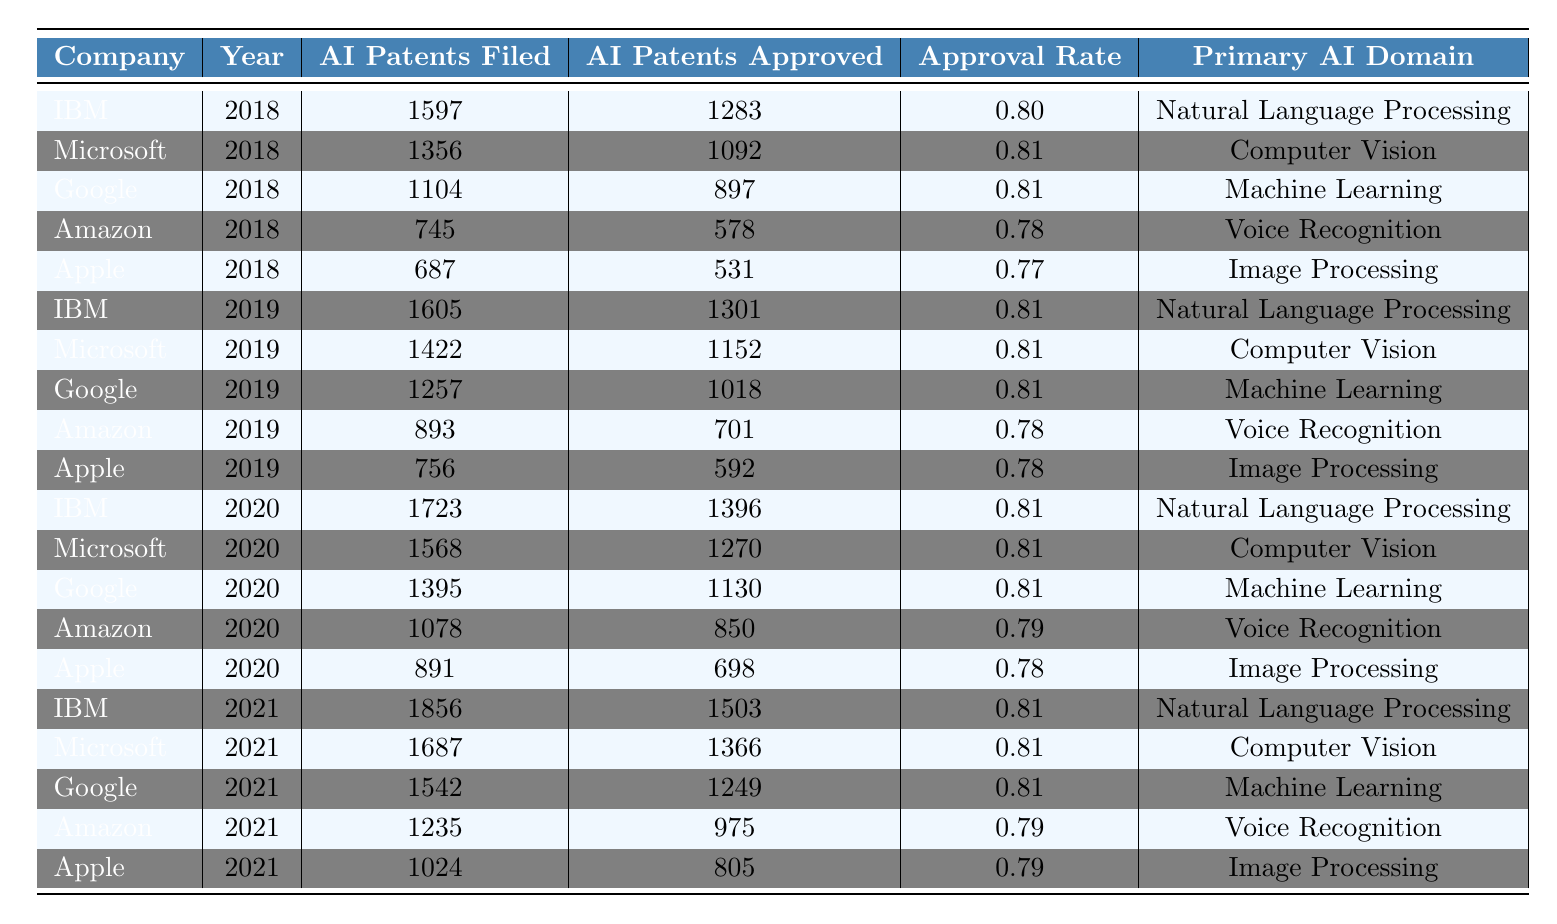What is the approval rate for IBM's AI patents in 2020? IBM filed 1723 AI patents in 2020 and had 1396 approved. The approval rate is calculated as 1396/1723, which equals 0.81.
Answer: 0.81 Which company had the highest number of AI patents filed in 2021? In 2021, IBM filed 1856 AI patents, which is higher than any other company in that year.
Answer: IBM What was the average approval rate for AI patents filed by Apple from 2018 to 2021? Apple's approval rates for 2018, 2019, 2020, and 2021 were 0.77, 0.78, 0.78, and 0.79 respectively. The average is (0.77 + 0.78 + 0.78 + 0.79) / 4 = 0.785.
Answer: 0.785 Did Amazon have a higher approval rate in 2020 compared to 2019? Amazon’s approval rates were 0.79 in 2020 and 0.78 in 2019. Since 0.79 is greater than 0.78, the statement is true.
Answer: Yes Which company consistently maintained an approval rate of 0.81 from 2018 to 2021? The approval rates for Microsoft from 2018 to 2021 were all 0.81, so it maintained this rate consistently.
Answer: Microsoft What is the total number of AI patents filed by Google from 2018 to 2021? Google filed 1104 in 2018, 1257 in 2019, 1395 in 2020, and 1542 in 2021. Summing these gives 1104 + 1257 + 1395 + 1542 = 4298.
Answer: 4298 Which year had the lowest approval rate for Amazon among the recorded years? Amazon's approval rates were 0.78 in both 2018 and 2019, and 0.79 in 2020 and 2021. Therefore, 0.78 is the lowest approval rate for Amazon, occurring in 2018 and 2019.
Answer: 2018 and 2019 Is the primary AI domain for IBM in all years listed the same? Looking at the primary AI domain for IBM from 2018 to 2021, it shows "Natural Language Processing" each year. Thus, it is consistent.
Answer: Yes How many more AI patents were approved for Microsoft compared to Amazon in 2021? Microsoft had 1366 patents approved in 2021 while Amazon had 975. The difference is calculated as 1366 - 975 = 391.
Answer: 391 For which AI domain did Apple have the lowest approval rate? Apple's approval rates were 0.77 for Image Processing in 2018. The other years had 0.78 in both 2019 and 2020, and 0.79 in 2021. Hence, 0.77 is the lowest.
Answer: Image Processing 